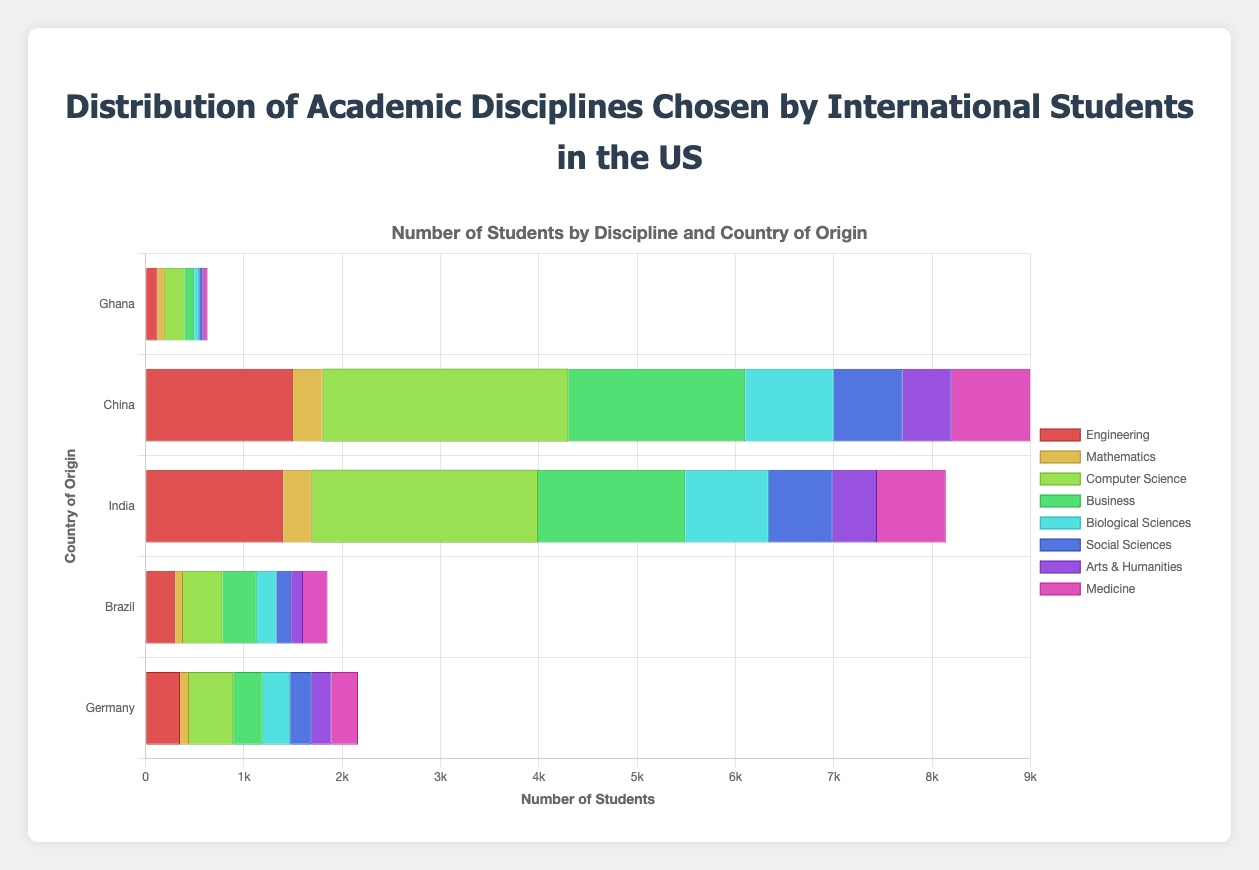Which discipline has the highest number of international students from India? To determine this, look for the highest bar corresponding to India across all disciplines. The height of the "Computer Science" bar is the largest for India.
Answer: Computer Science How does the number of international students from China studying Business compare to those from India? Compare the "Business" bars for China and India. The bar for China is higher at 1800 students, whereas India's bar stands at 1500 students.
Answer: China has more students What is the total number of international students from Ghana across all disciplines? Sum up all the student counts for Ghana across the disciplines: 120 (Engineering) + 75 (Mathematics) + 200 (Computer Science) + 100 (Business) + 50 (Biological Sciences) + 30 (Social Sciences) + 15 (Arts & Humanities) + 40 (Medicine) = 630.
Answer: 630 Between Germany and Brazil, which country has more international students in Social Sciences? Compare the "Social Sciences" bars for Germany and Brazil. Germany has 220 students, whereas Brazil has 150 students.
Answer: Germany What is the average number of international students from Brazil pursuing Mathematics, Engineering, and Computer Science? Calculate the average by summing the student counts for the three disciplines for Brazil, and then dividing by 3. (80 + 300 + 400) / 3 = 780 / 3 = 260.
Answer: 260 Which academic discipline has the least representation from China? Look for the lowest bar among the disciplines for China. "Arts & Humanities" has the fewest students at 500.
Answer: Arts & Humanities What is the difference in the number of students between the most popular discipline for students from China and the least popular discipline for students from Ghana? The most popular discipline for China is Computer Science with 2500 students. The least popular discipline for Ghana is Arts & Humanities with 15 students. The difference is 2500 - 15 = 2485.
Answer: 2485 How do the number of students from Germany studying Medicine compare to those studying Business? Compare the "Medicine" and "Business" bars for Germany. "Medicine" has 270 students, while "Business" has 300 students.
Answer: Business has more students Which country has the most international students in Biological Sciences? Look for the highest bar in the "Biological Sciences" category. China has the most with 900 students.
Answer: China 